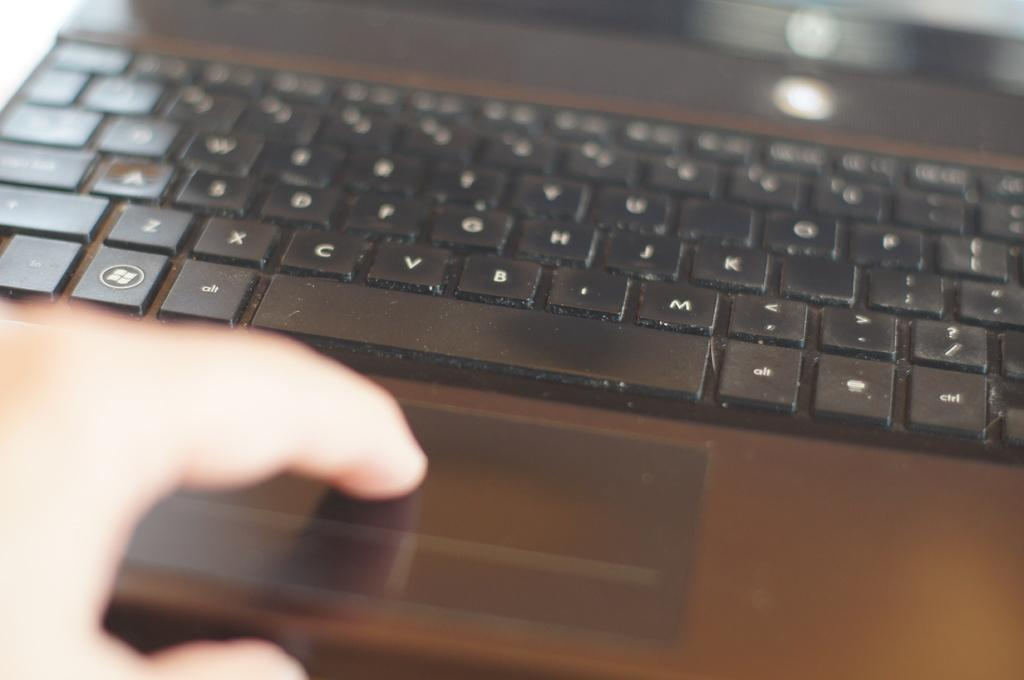<image>
Give a short and clear explanation of the subsequent image. A black keyboard, one of the keys reads alt 